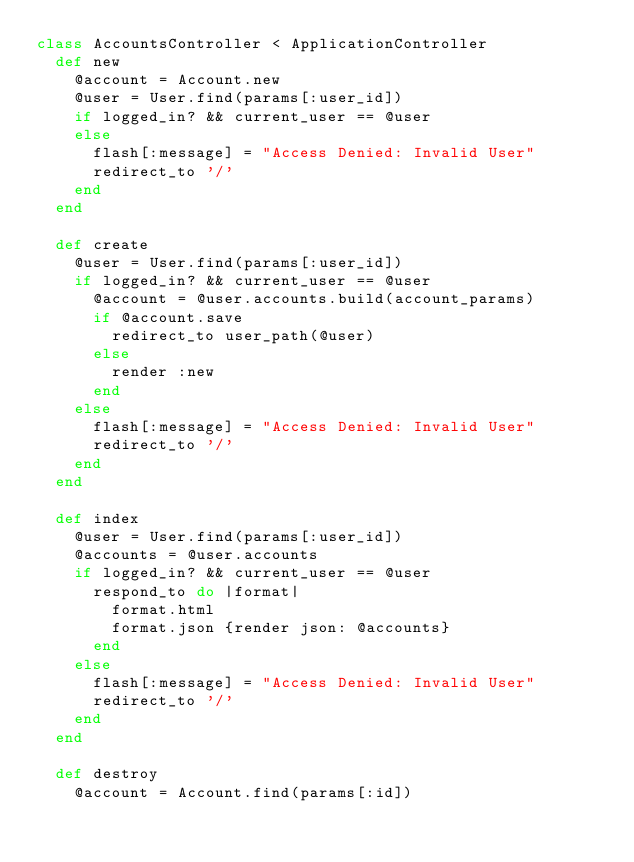Convert code to text. <code><loc_0><loc_0><loc_500><loc_500><_Ruby_>class AccountsController < ApplicationController
  def new
    @account = Account.new
    @user = User.find(params[:user_id])
    if logged_in? && current_user == @user
    else
      flash[:message] = "Access Denied: Invalid User"
      redirect_to '/'
    end
  end

  def create
    @user = User.find(params[:user_id])
    if logged_in? && current_user == @user
      @account = @user.accounts.build(account_params)
      if @account.save
        redirect_to user_path(@user)
      else
        render :new
      end
    else
      flash[:message] = "Access Denied: Invalid User"
      redirect_to '/'
    end
  end

  def index
    @user = User.find(params[:user_id])
    @accounts = @user.accounts
    if logged_in? && current_user == @user
      respond_to do |format|
        format.html
        format.json {render json: @accounts}
      end
    else
      flash[:message] = "Access Denied: Invalid User"
      redirect_to '/'
    end
  end

  def destroy
    @account = Account.find(params[:id])</code> 